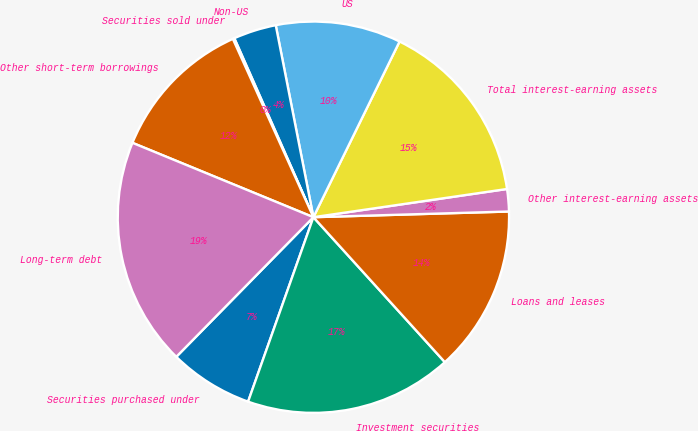Convert chart to OTSL. <chart><loc_0><loc_0><loc_500><loc_500><pie_chart><fcel>Securities purchased under<fcel>Investment securities<fcel>Loans and leases<fcel>Other interest-earning assets<fcel>Total interest-earning assets<fcel>US<fcel>Non-US<fcel>Securities sold under<fcel>Other short-term borrowings<fcel>Long-term debt<nl><fcel>6.94%<fcel>17.14%<fcel>13.74%<fcel>1.84%<fcel>15.44%<fcel>10.34%<fcel>3.54%<fcel>0.13%<fcel>12.04%<fcel>18.85%<nl></chart> 